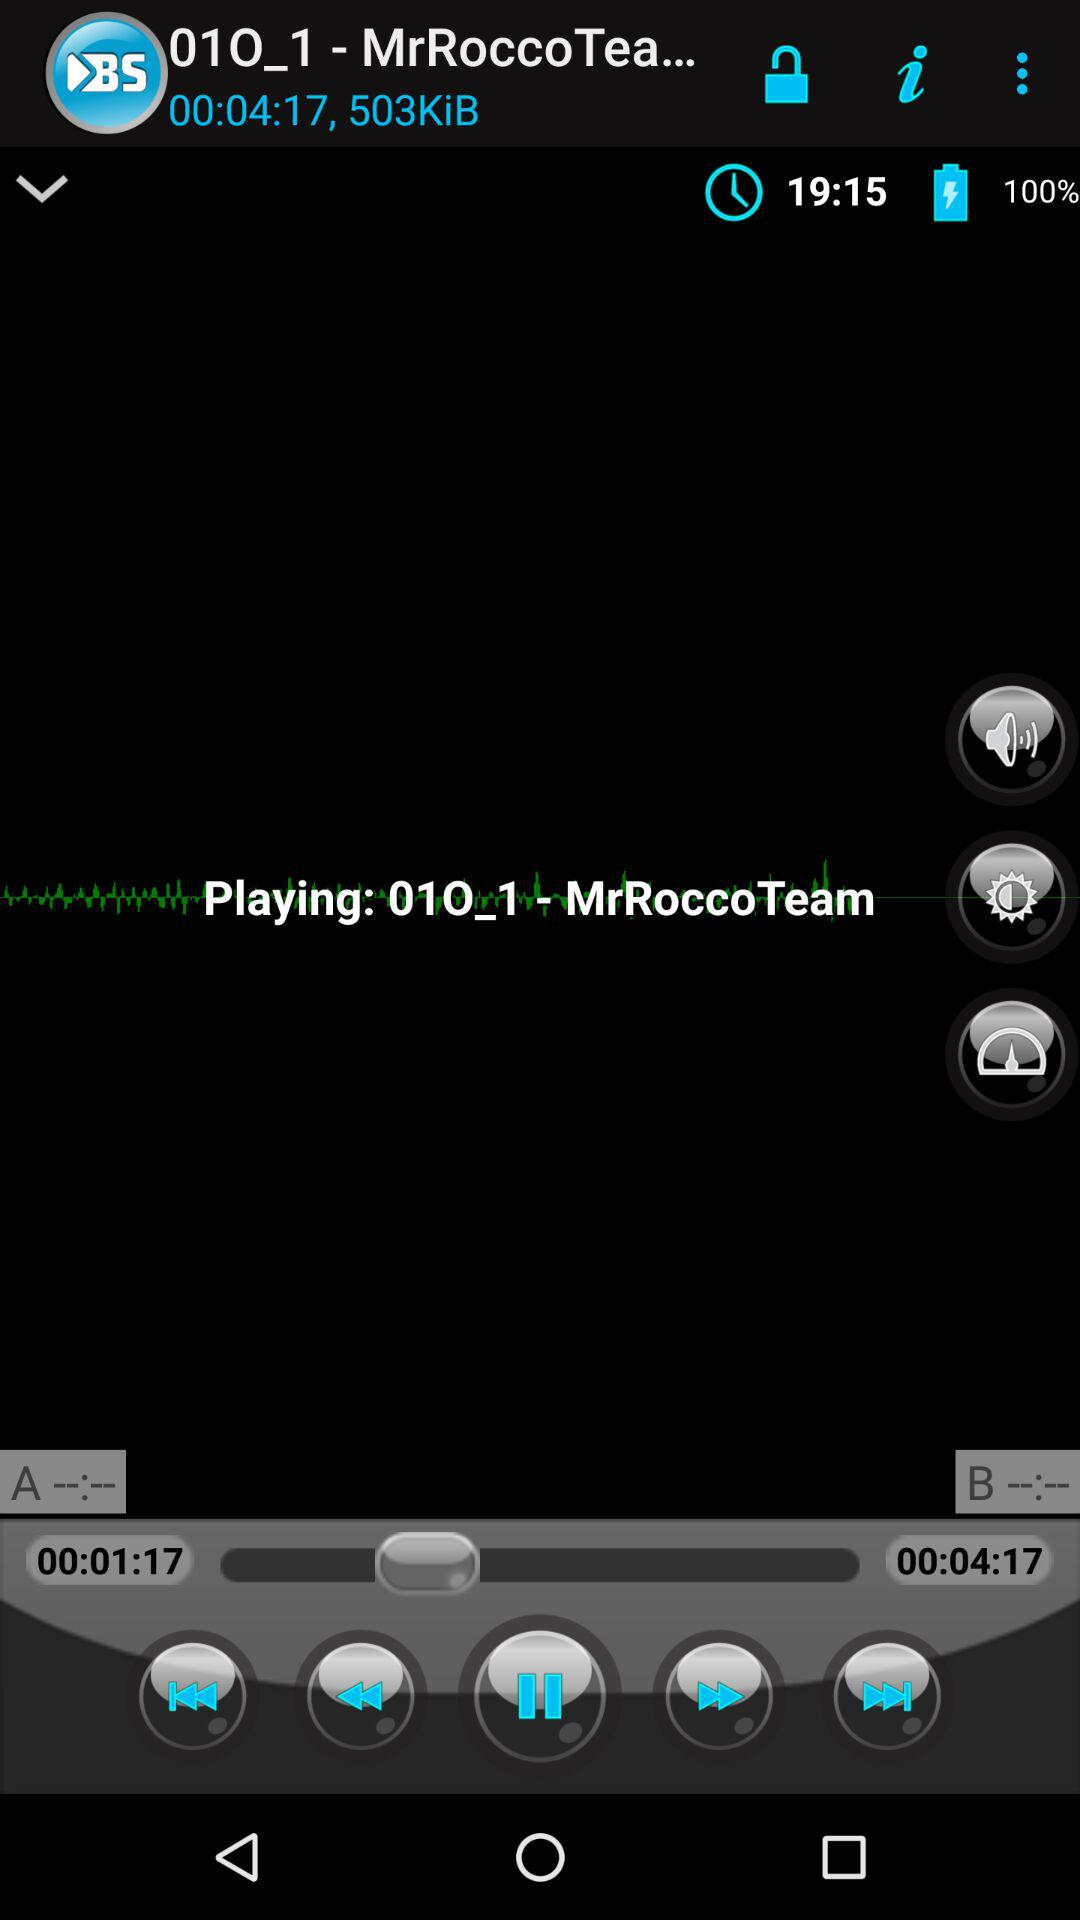What is the percentage of the battery? The percentage is 100. 